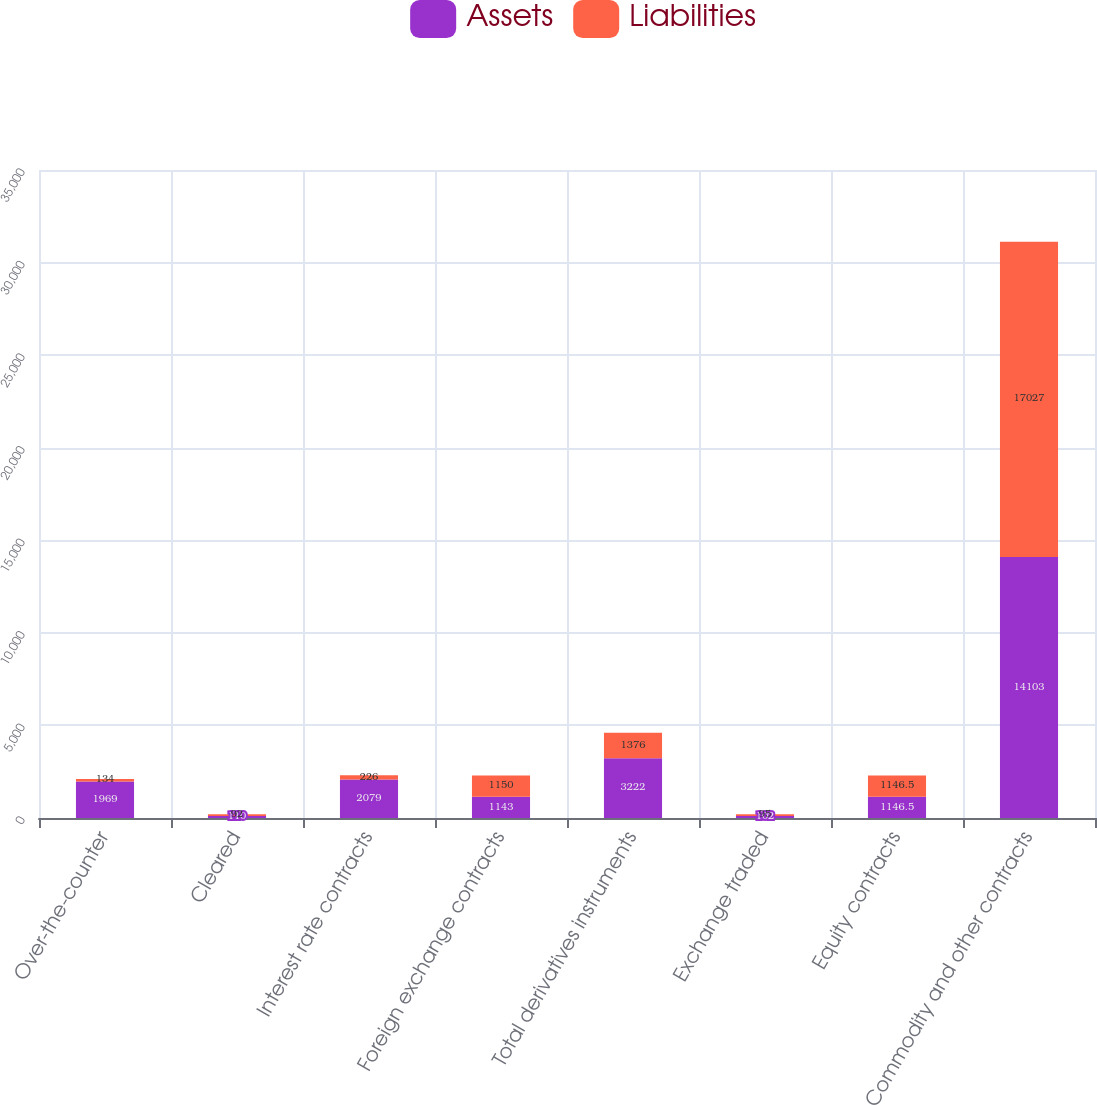Convert chart to OTSL. <chart><loc_0><loc_0><loc_500><loc_500><stacked_bar_chart><ecel><fcel>Over-the-counter<fcel>Cleared<fcel>Interest rate contracts<fcel>Foreign exchange contracts<fcel>Total derivatives instruments<fcel>Exchange traded<fcel>Equity contracts<fcel>Commodity and other contracts<nl><fcel>Assets<fcel>1969<fcel>110<fcel>2079<fcel>1143<fcel>3222<fcel>102<fcel>1146.5<fcel>14103<nl><fcel>Liabilities<fcel>134<fcel>92<fcel>226<fcel>1150<fcel>1376<fcel>95<fcel>1146.5<fcel>17027<nl></chart> 